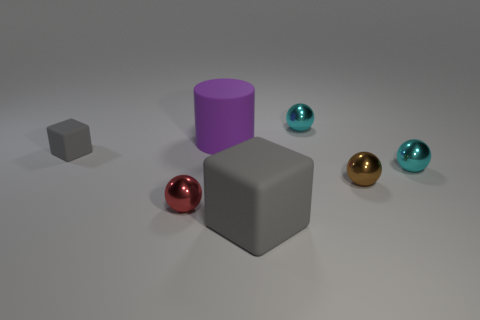Add 3 cyan balls. How many objects exist? 10 Subtract all purple spheres. Subtract all red blocks. How many spheres are left? 4 Subtract all cylinders. How many objects are left? 6 Subtract all tiny brown balls. Subtract all rubber things. How many objects are left? 3 Add 7 red metal objects. How many red metal objects are left? 8 Add 7 tiny gray objects. How many tiny gray objects exist? 8 Subtract 2 cyan balls. How many objects are left? 5 